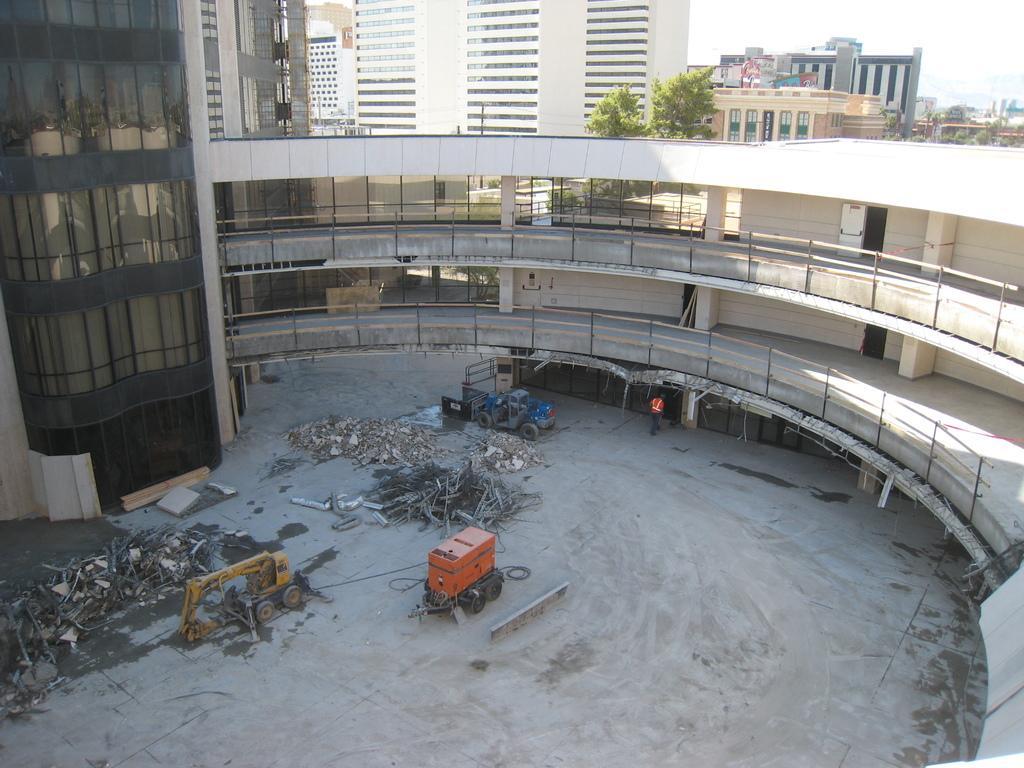Please provide a concise description of this image. In this image I can see a crane on the ground and at the back, I can see the buildings and there is a person. 